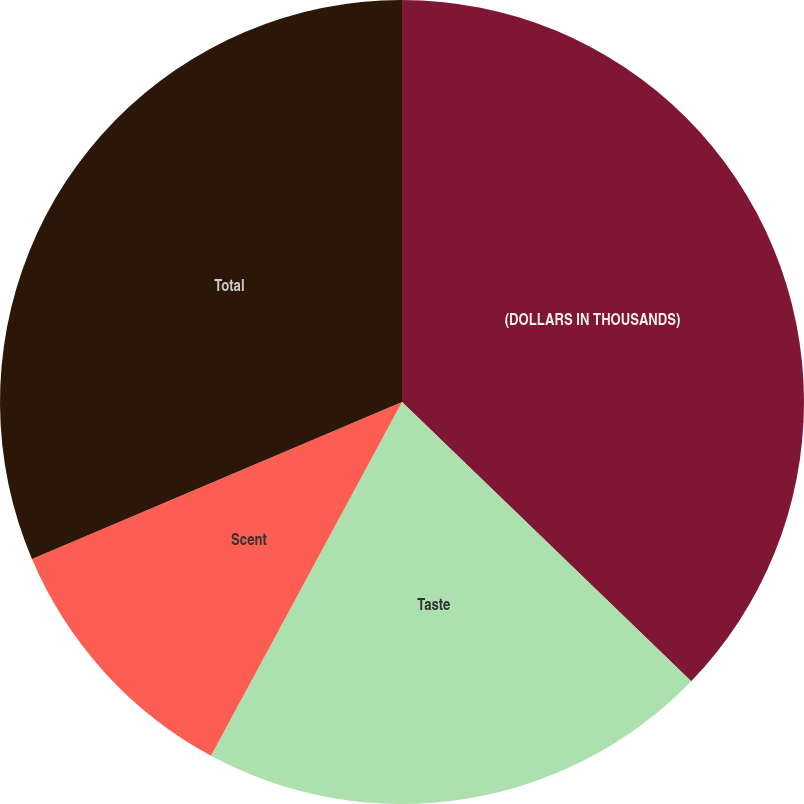Convert chart. <chart><loc_0><loc_0><loc_500><loc_500><pie_chart><fcel>(DOLLARS IN THOUSANDS)<fcel>Taste<fcel>Scent<fcel>Total<nl><fcel>37.22%<fcel>20.66%<fcel>10.73%<fcel>31.39%<nl></chart> 